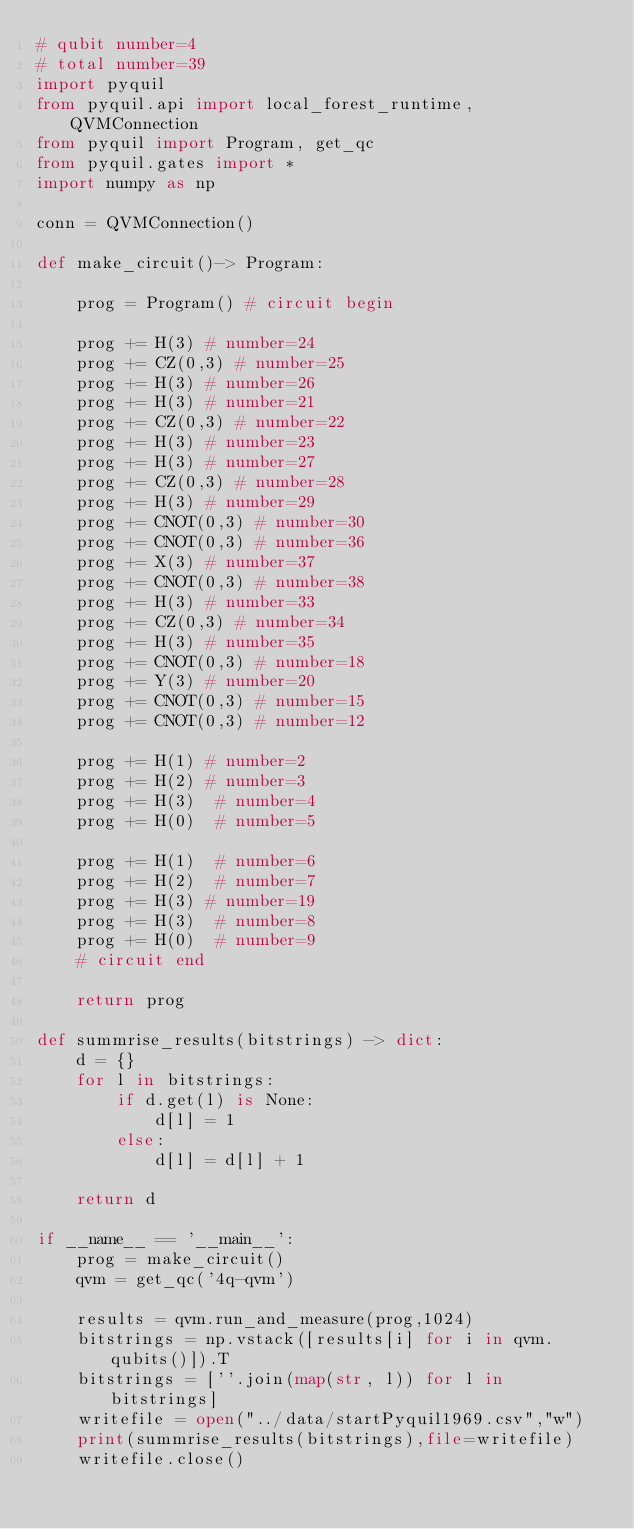<code> <loc_0><loc_0><loc_500><loc_500><_Python_># qubit number=4
# total number=39
import pyquil
from pyquil.api import local_forest_runtime, QVMConnection
from pyquil import Program, get_qc
from pyquil.gates import *
import numpy as np

conn = QVMConnection()

def make_circuit()-> Program:

    prog = Program() # circuit begin

    prog += H(3) # number=24
    prog += CZ(0,3) # number=25
    prog += H(3) # number=26
    prog += H(3) # number=21
    prog += CZ(0,3) # number=22
    prog += H(3) # number=23
    prog += H(3) # number=27
    prog += CZ(0,3) # number=28
    prog += H(3) # number=29
    prog += CNOT(0,3) # number=30
    prog += CNOT(0,3) # number=36
    prog += X(3) # number=37
    prog += CNOT(0,3) # number=38
    prog += H(3) # number=33
    prog += CZ(0,3) # number=34
    prog += H(3) # number=35
    prog += CNOT(0,3) # number=18
    prog += Y(3) # number=20
    prog += CNOT(0,3) # number=15
    prog += CNOT(0,3) # number=12

    prog += H(1) # number=2
    prog += H(2) # number=3
    prog += H(3)  # number=4
    prog += H(0)  # number=5

    prog += H(1)  # number=6
    prog += H(2)  # number=7
    prog += H(3) # number=19
    prog += H(3)  # number=8
    prog += H(0)  # number=9
    # circuit end

    return prog

def summrise_results(bitstrings) -> dict:
    d = {}
    for l in bitstrings:
        if d.get(l) is None:
            d[l] = 1
        else:
            d[l] = d[l] + 1

    return d

if __name__ == '__main__':
    prog = make_circuit()
    qvm = get_qc('4q-qvm')

    results = qvm.run_and_measure(prog,1024)
    bitstrings = np.vstack([results[i] for i in qvm.qubits()]).T
    bitstrings = [''.join(map(str, l)) for l in bitstrings]
    writefile = open("../data/startPyquil1969.csv","w")
    print(summrise_results(bitstrings),file=writefile)
    writefile.close()

</code> 